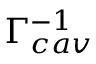Convert formula to latex. <formula><loc_0><loc_0><loc_500><loc_500>\Gamma _ { c a v } ^ { - 1 }</formula> 